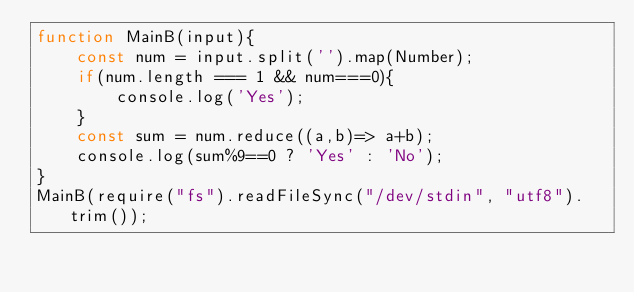Convert code to text. <code><loc_0><loc_0><loc_500><loc_500><_JavaScript_>function MainB(input){
    const num = input.split('').map(Number);
    if(num.length === 1 && num===0){
        console.log('Yes');
    }
    const sum = num.reduce((a,b)=> a+b);
    console.log(sum%9==0 ? 'Yes' : 'No');
}
MainB(require("fs").readFileSync("/dev/stdin", "utf8").trim());
</code> 